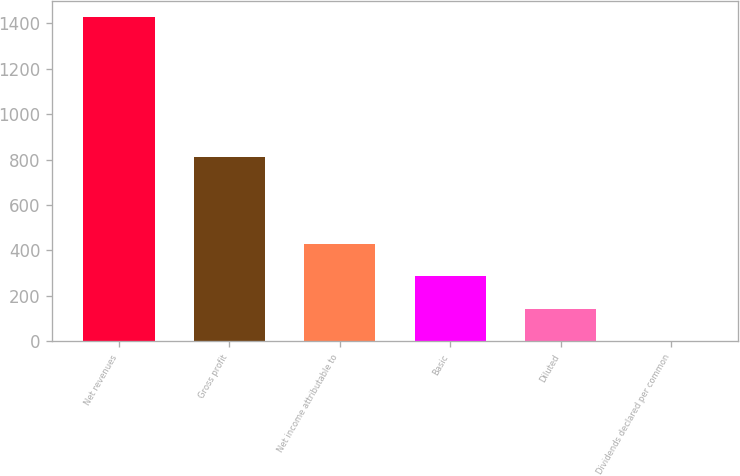<chart> <loc_0><loc_0><loc_500><loc_500><bar_chart><fcel>Net revenues<fcel>Gross profit<fcel>Net income attributable to<fcel>Basic<fcel>Diluted<fcel>Dividends declared per common<nl><fcel>1426.9<fcel>810.3<fcel>428.21<fcel>285.54<fcel>142.87<fcel>0.2<nl></chart> 